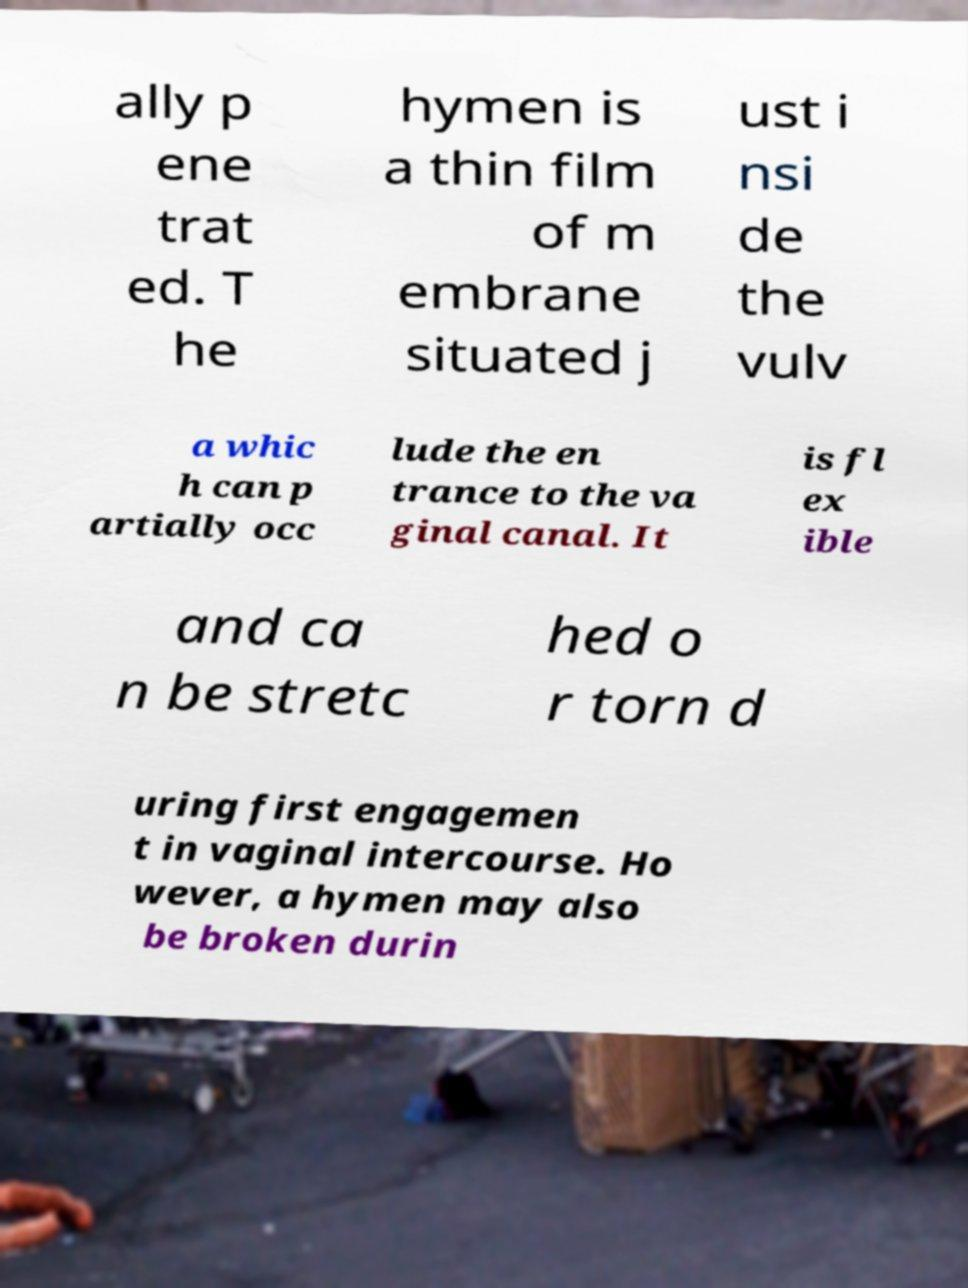What messages or text are displayed in this image? I need them in a readable, typed format. ally p ene trat ed. T he hymen is a thin film of m embrane situated j ust i nsi de the vulv a whic h can p artially occ lude the en trance to the va ginal canal. It is fl ex ible and ca n be stretc hed o r torn d uring first engagemen t in vaginal intercourse. Ho wever, a hymen may also be broken durin 